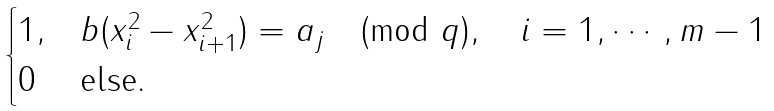Convert formula to latex. <formula><loc_0><loc_0><loc_500><loc_500>\begin{cases} 1 , & b ( x _ { i } ^ { 2 } - x _ { i + 1 } ^ { 2 } ) = a _ { j } \pmod { q } , \quad i = 1 , \cdots , m - 1 \\ 0 & \text {else.} \end{cases}</formula> 